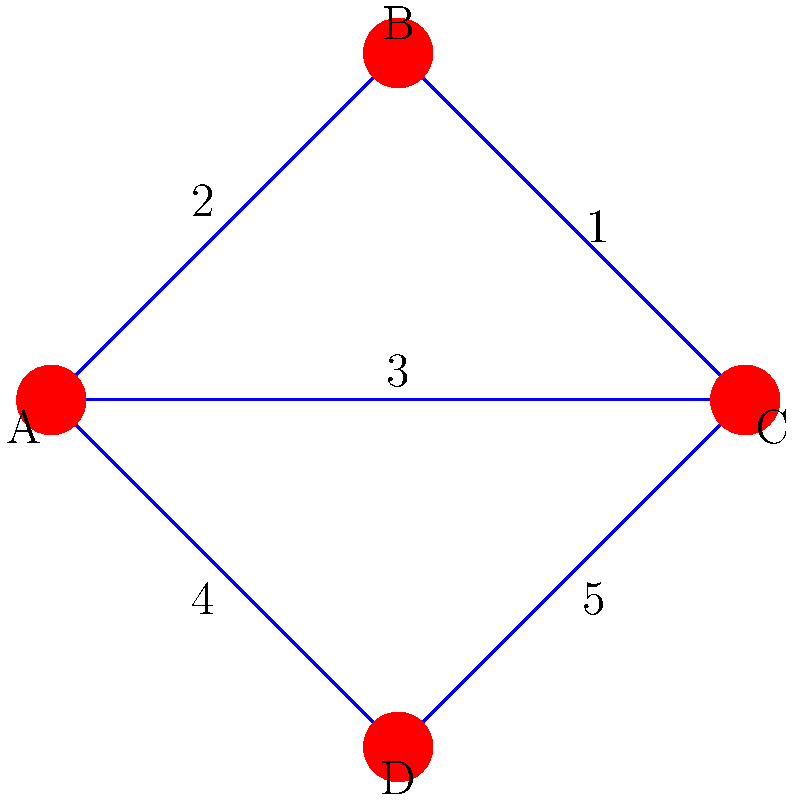Consider the quantum network topology shown above, where nodes represent quantum repeaters and edge weights represent the fidelity of entanglement between connected nodes. What is the optimal path for quantum state transfer from node A to node C that maximizes the overall fidelity, and what is the resulting fidelity of this path? To solve this problem, we need to follow these steps:

1. Identify all possible paths from A to C:
   Path 1: A → B → C
   Path 2: A → C
   Path 3: A → D → C

2. Calculate the fidelity for each path:
   For quantum state transfer, the fidelity of a path is the product of the fidelities of its edges.

   Path 1: A → B → C
   Fidelity = 2 × 1 = 2

   Path 2: A → C
   Fidelity = 3

   Path 3: A → D → C
   Fidelity = 4 × 5 = 20

3. Compare the fidelities:
   Path 1: 2
   Path 2: 3
   Path 3: 20

4. Identify the path with the highest fidelity:
   Path 3 (A → D → C) has the highest fidelity of 20.

Therefore, the optimal path for quantum state transfer from node A to node C is A → D → C, with a resulting fidelity of 20.
Answer: A → D → C, fidelity = 20 